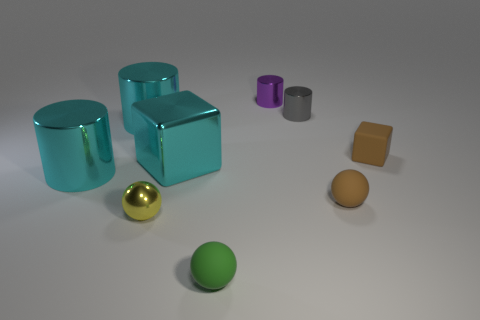There is a big block that is the same material as the yellow ball; what is its color?
Provide a short and direct response. Cyan. Do the purple thing and the matte object that is behind the big cyan cube have the same size?
Your response must be concise. Yes. What is the shape of the purple thing?
Provide a succinct answer. Cylinder. How many tiny matte blocks are the same color as the big shiny block?
Provide a short and direct response. 0. The other small object that is the same shape as the small gray metal thing is what color?
Provide a succinct answer. Purple. There is a cube that is to the left of the brown cube; how many metallic cylinders are to the right of it?
Provide a succinct answer. 2. How many balls are tiny objects or gray matte things?
Ensure brevity in your answer.  3. Is there a large purple shiny ball?
Your answer should be compact. No. There is a gray shiny thing that is the same shape as the purple metallic thing; what is its size?
Provide a succinct answer. Small. There is a brown thing that is behind the ball behind the small yellow metallic ball; what shape is it?
Your answer should be very brief. Cube. 